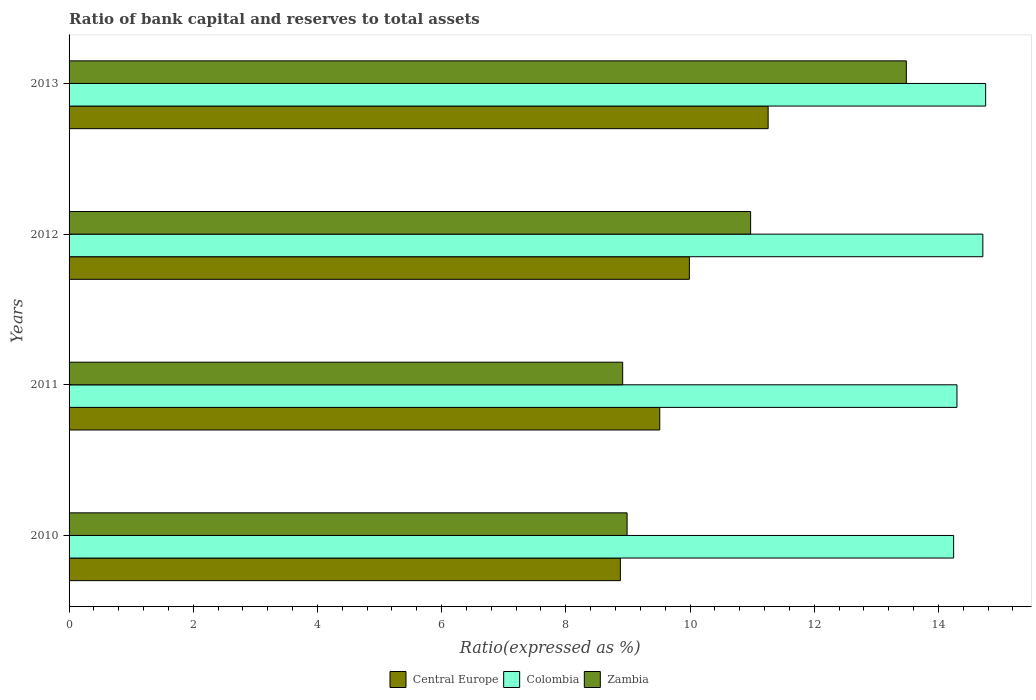Are the number of bars per tick equal to the number of legend labels?
Offer a terse response. Yes. How many bars are there on the 1st tick from the top?
Give a very brief answer. 3. What is the label of the 3rd group of bars from the top?
Ensure brevity in your answer.  2011. In how many cases, is the number of bars for a given year not equal to the number of legend labels?
Offer a terse response. 0. What is the ratio of bank capital and reserves to total assets in Central Europe in 2013?
Your answer should be very brief. 11.26. Across all years, what is the maximum ratio of bank capital and reserves to total assets in Zambia?
Your answer should be very brief. 13.48. Across all years, what is the minimum ratio of bank capital and reserves to total assets in Zambia?
Offer a very short reply. 8.92. In which year was the ratio of bank capital and reserves to total assets in Colombia minimum?
Your answer should be compact. 2010. What is the total ratio of bank capital and reserves to total assets in Central Europe in the graph?
Offer a very short reply. 39.64. What is the difference between the ratio of bank capital and reserves to total assets in Colombia in 2011 and that in 2012?
Offer a very short reply. -0.42. What is the difference between the ratio of bank capital and reserves to total assets in Central Europe in 2010 and the ratio of bank capital and reserves to total assets in Colombia in 2012?
Provide a short and direct response. -5.84. What is the average ratio of bank capital and reserves to total assets in Colombia per year?
Your answer should be compact. 14.51. In the year 2013, what is the difference between the ratio of bank capital and reserves to total assets in Central Europe and ratio of bank capital and reserves to total assets in Colombia?
Give a very brief answer. -3.5. In how many years, is the ratio of bank capital and reserves to total assets in Colombia greater than 4.8 %?
Provide a short and direct response. 4. What is the ratio of the ratio of bank capital and reserves to total assets in Colombia in 2012 to that in 2013?
Offer a terse response. 1. What is the difference between the highest and the second highest ratio of bank capital and reserves to total assets in Zambia?
Your answer should be very brief. 2.51. What is the difference between the highest and the lowest ratio of bank capital and reserves to total assets in Central Europe?
Your answer should be compact. 2.38. Is the sum of the ratio of bank capital and reserves to total assets in Zambia in 2010 and 2013 greater than the maximum ratio of bank capital and reserves to total assets in Central Europe across all years?
Provide a succinct answer. Yes. What does the 3rd bar from the top in 2013 represents?
Make the answer very short. Central Europe. What does the 2nd bar from the bottom in 2010 represents?
Offer a very short reply. Colombia. Is it the case that in every year, the sum of the ratio of bank capital and reserves to total assets in Central Europe and ratio of bank capital and reserves to total assets in Zambia is greater than the ratio of bank capital and reserves to total assets in Colombia?
Provide a short and direct response. Yes. How many years are there in the graph?
Offer a terse response. 4. Does the graph contain any zero values?
Your answer should be compact. No. Where does the legend appear in the graph?
Offer a terse response. Bottom center. How many legend labels are there?
Offer a very short reply. 3. How are the legend labels stacked?
Your answer should be compact. Horizontal. What is the title of the graph?
Offer a very short reply. Ratio of bank capital and reserves to total assets. What is the label or title of the X-axis?
Make the answer very short. Ratio(expressed as %). What is the label or title of the Y-axis?
Your answer should be compact. Years. What is the Ratio(expressed as %) of Central Europe in 2010?
Provide a short and direct response. 8.88. What is the Ratio(expressed as %) of Colombia in 2010?
Ensure brevity in your answer.  14.25. What is the Ratio(expressed as %) in Zambia in 2010?
Provide a succinct answer. 8.99. What is the Ratio(expressed as %) in Central Europe in 2011?
Provide a short and direct response. 9.51. What is the Ratio(expressed as %) in Colombia in 2011?
Offer a terse response. 14.3. What is the Ratio(expressed as %) in Zambia in 2011?
Ensure brevity in your answer.  8.92. What is the Ratio(expressed as %) of Central Europe in 2012?
Offer a very short reply. 9.99. What is the Ratio(expressed as %) in Colombia in 2012?
Your response must be concise. 14.72. What is the Ratio(expressed as %) of Zambia in 2012?
Your answer should be compact. 10.98. What is the Ratio(expressed as %) in Central Europe in 2013?
Your answer should be compact. 11.26. What is the Ratio(expressed as %) in Colombia in 2013?
Make the answer very short. 14.76. What is the Ratio(expressed as %) of Zambia in 2013?
Your answer should be very brief. 13.48. Across all years, what is the maximum Ratio(expressed as %) of Central Europe?
Provide a short and direct response. 11.26. Across all years, what is the maximum Ratio(expressed as %) in Colombia?
Ensure brevity in your answer.  14.76. Across all years, what is the maximum Ratio(expressed as %) of Zambia?
Provide a succinct answer. 13.48. Across all years, what is the minimum Ratio(expressed as %) of Central Europe?
Keep it short and to the point. 8.88. Across all years, what is the minimum Ratio(expressed as %) of Colombia?
Offer a terse response. 14.25. Across all years, what is the minimum Ratio(expressed as %) of Zambia?
Your response must be concise. 8.92. What is the total Ratio(expressed as %) of Central Europe in the graph?
Keep it short and to the point. 39.64. What is the total Ratio(expressed as %) in Colombia in the graph?
Give a very brief answer. 58.02. What is the total Ratio(expressed as %) of Zambia in the graph?
Offer a terse response. 42.36. What is the difference between the Ratio(expressed as %) of Central Europe in 2010 and that in 2011?
Provide a short and direct response. -0.63. What is the difference between the Ratio(expressed as %) in Colombia in 2010 and that in 2011?
Offer a terse response. -0.05. What is the difference between the Ratio(expressed as %) in Zambia in 2010 and that in 2011?
Offer a very short reply. 0.07. What is the difference between the Ratio(expressed as %) of Central Europe in 2010 and that in 2012?
Offer a very short reply. -1.11. What is the difference between the Ratio(expressed as %) in Colombia in 2010 and that in 2012?
Ensure brevity in your answer.  -0.47. What is the difference between the Ratio(expressed as %) in Zambia in 2010 and that in 2012?
Keep it short and to the point. -1.99. What is the difference between the Ratio(expressed as %) of Central Europe in 2010 and that in 2013?
Keep it short and to the point. -2.38. What is the difference between the Ratio(expressed as %) in Colombia in 2010 and that in 2013?
Offer a terse response. -0.52. What is the difference between the Ratio(expressed as %) of Zambia in 2010 and that in 2013?
Give a very brief answer. -4.5. What is the difference between the Ratio(expressed as %) in Central Europe in 2011 and that in 2012?
Your answer should be compact. -0.48. What is the difference between the Ratio(expressed as %) in Colombia in 2011 and that in 2012?
Your answer should be very brief. -0.42. What is the difference between the Ratio(expressed as %) of Zambia in 2011 and that in 2012?
Your answer should be compact. -2.06. What is the difference between the Ratio(expressed as %) of Central Europe in 2011 and that in 2013?
Keep it short and to the point. -1.75. What is the difference between the Ratio(expressed as %) of Colombia in 2011 and that in 2013?
Give a very brief answer. -0.46. What is the difference between the Ratio(expressed as %) in Zambia in 2011 and that in 2013?
Your answer should be very brief. -4.57. What is the difference between the Ratio(expressed as %) in Central Europe in 2012 and that in 2013?
Make the answer very short. -1.27. What is the difference between the Ratio(expressed as %) in Colombia in 2012 and that in 2013?
Give a very brief answer. -0.05. What is the difference between the Ratio(expressed as %) of Zambia in 2012 and that in 2013?
Your answer should be very brief. -2.51. What is the difference between the Ratio(expressed as %) in Central Europe in 2010 and the Ratio(expressed as %) in Colombia in 2011?
Provide a succinct answer. -5.42. What is the difference between the Ratio(expressed as %) in Central Europe in 2010 and the Ratio(expressed as %) in Zambia in 2011?
Provide a short and direct response. -0.04. What is the difference between the Ratio(expressed as %) of Colombia in 2010 and the Ratio(expressed as %) of Zambia in 2011?
Give a very brief answer. 5.33. What is the difference between the Ratio(expressed as %) of Central Europe in 2010 and the Ratio(expressed as %) of Colombia in 2012?
Your answer should be compact. -5.84. What is the difference between the Ratio(expressed as %) of Central Europe in 2010 and the Ratio(expressed as %) of Zambia in 2012?
Make the answer very short. -2.1. What is the difference between the Ratio(expressed as %) of Colombia in 2010 and the Ratio(expressed as %) of Zambia in 2012?
Your answer should be compact. 3.27. What is the difference between the Ratio(expressed as %) of Central Europe in 2010 and the Ratio(expressed as %) of Colombia in 2013?
Keep it short and to the point. -5.88. What is the difference between the Ratio(expressed as %) in Central Europe in 2010 and the Ratio(expressed as %) in Zambia in 2013?
Give a very brief answer. -4.61. What is the difference between the Ratio(expressed as %) in Colombia in 2010 and the Ratio(expressed as %) in Zambia in 2013?
Ensure brevity in your answer.  0.76. What is the difference between the Ratio(expressed as %) in Central Europe in 2011 and the Ratio(expressed as %) in Colombia in 2012?
Offer a very short reply. -5.2. What is the difference between the Ratio(expressed as %) in Central Europe in 2011 and the Ratio(expressed as %) in Zambia in 2012?
Your answer should be very brief. -1.46. What is the difference between the Ratio(expressed as %) in Colombia in 2011 and the Ratio(expressed as %) in Zambia in 2012?
Provide a succinct answer. 3.32. What is the difference between the Ratio(expressed as %) in Central Europe in 2011 and the Ratio(expressed as %) in Colombia in 2013?
Provide a short and direct response. -5.25. What is the difference between the Ratio(expressed as %) in Central Europe in 2011 and the Ratio(expressed as %) in Zambia in 2013?
Offer a very short reply. -3.97. What is the difference between the Ratio(expressed as %) in Colombia in 2011 and the Ratio(expressed as %) in Zambia in 2013?
Keep it short and to the point. 0.82. What is the difference between the Ratio(expressed as %) of Central Europe in 2012 and the Ratio(expressed as %) of Colombia in 2013?
Make the answer very short. -4.77. What is the difference between the Ratio(expressed as %) in Central Europe in 2012 and the Ratio(expressed as %) in Zambia in 2013?
Give a very brief answer. -3.49. What is the difference between the Ratio(expressed as %) in Colombia in 2012 and the Ratio(expressed as %) in Zambia in 2013?
Your answer should be compact. 1.23. What is the average Ratio(expressed as %) in Central Europe per year?
Offer a very short reply. 9.91. What is the average Ratio(expressed as %) in Colombia per year?
Provide a succinct answer. 14.51. What is the average Ratio(expressed as %) in Zambia per year?
Give a very brief answer. 10.59. In the year 2010, what is the difference between the Ratio(expressed as %) of Central Europe and Ratio(expressed as %) of Colombia?
Keep it short and to the point. -5.37. In the year 2010, what is the difference between the Ratio(expressed as %) in Central Europe and Ratio(expressed as %) in Zambia?
Offer a very short reply. -0.11. In the year 2010, what is the difference between the Ratio(expressed as %) of Colombia and Ratio(expressed as %) of Zambia?
Provide a short and direct response. 5.26. In the year 2011, what is the difference between the Ratio(expressed as %) in Central Europe and Ratio(expressed as %) in Colombia?
Offer a terse response. -4.79. In the year 2011, what is the difference between the Ratio(expressed as %) of Central Europe and Ratio(expressed as %) of Zambia?
Give a very brief answer. 0.6. In the year 2011, what is the difference between the Ratio(expressed as %) of Colombia and Ratio(expressed as %) of Zambia?
Your answer should be compact. 5.38. In the year 2012, what is the difference between the Ratio(expressed as %) of Central Europe and Ratio(expressed as %) of Colombia?
Provide a succinct answer. -4.73. In the year 2012, what is the difference between the Ratio(expressed as %) in Central Europe and Ratio(expressed as %) in Zambia?
Make the answer very short. -0.99. In the year 2012, what is the difference between the Ratio(expressed as %) in Colombia and Ratio(expressed as %) in Zambia?
Provide a succinct answer. 3.74. In the year 2013, what is the difference between the Ratio(expressed as %) in Central Europe and Ratio(expressed as %) in Colombia?
Your answer should be very brief. -3.5. In the year 2013, what is the difference between the Ratio(expressed as %) in Central Europe and Ratio(expressed as %) in Zambia?
Your response must be concise. -2.23. In the year 2013, what is the difference between the Ratio(expressed as %) of Colombia and Ratio(expressed as %) of Zambia?
Your response must be concise. 1.28. What is the ratio of the Ratio(expressed as %) of Colombia in 2010 to that in 2011?
Keep it short and to the point. 1. What is the ratio of the Ratio(expressed as %) of Central Europe in 2010 to that in 2012?
Your answer should be very brief. 0.89. What is the ratio of the Ratio(expressed as %) of Zambia in 2010 to that in 2012?
Your response must be concise. 0.82. What is the ratio of the Ratio(expressed as %) of Central Europe in 2010 to that in 2013?
Your answer should be compact. 0.79. What is the ratio of the Ratio(expressed as %) in Zambia in 2010 to that in 2013?
Your answer should be very brief. 0.67. What is the ratio of the Ratio(expressed as %) of Central Europe in 2011 to that in 2012?
Provide a short and direct response. 0.95. What is the ratio of the Ratio(expressed as %) in Colombia in 2011 to that in 2012?
Your response must be concise. 0.97. What is the ratio of the Ratio(expressed as %) in Zambia in 2011 to that in 2012?
Offer a terse response. 0.81. What is the ratio of the Ratio(expressed as %) of Central Europe in 2011 to that in 2013?
Your answer should be very brief. 0.84. What is the ratio of the Ratio(expressed as %) in Colombia in 2011 to that in 2013?
Your answer should be very brief. 0.97. What is the ratio of the Ratio(expressed as %) in Zambia in 2011 to that in 2013?
Ensure brevity in your answer.  0.66. What is the ratio of the Ratio(expressed as %) of Central Europe in 2012 to that in 2013?
Offer a very short reply. 0.89. What is the ratio of the Ratio(expressed as %) of Zambia in 2012 to that in 2013?
Ensure brevity in your answer.  0.81. What is the difference between the highest and the second highest Ratio(expressed as %) of Central Europe?
Provide a short and direct response. 1.27. What is the difference between the highest and the second highest Ratio(expressed as %) in Colombia?
Give a very brief answer. 0.05. What is the difference between the highest and the second highest Ratio(expressed as %) in Zambia?
Make the answer very short. 2.51. What is the difference between the highest and the lowest Ratio(expressed as %) in Central Europe?
Your response must be concise. 2.38. What is the difference between the highest and the lowest Ratio(expressed as %) of Colombia?
Provide a short and direct response. 0.52. What is the difference between the highest and the lowest Ratio(expressed as %) in Zambia?
Make the answer very short. 4.57. 